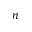<formula> <loc_0><loc_0><loc_500><loc_500>n</formula> 